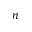<formula> <loc_0><loc_0><loc_500><loc_500>n</formula> 